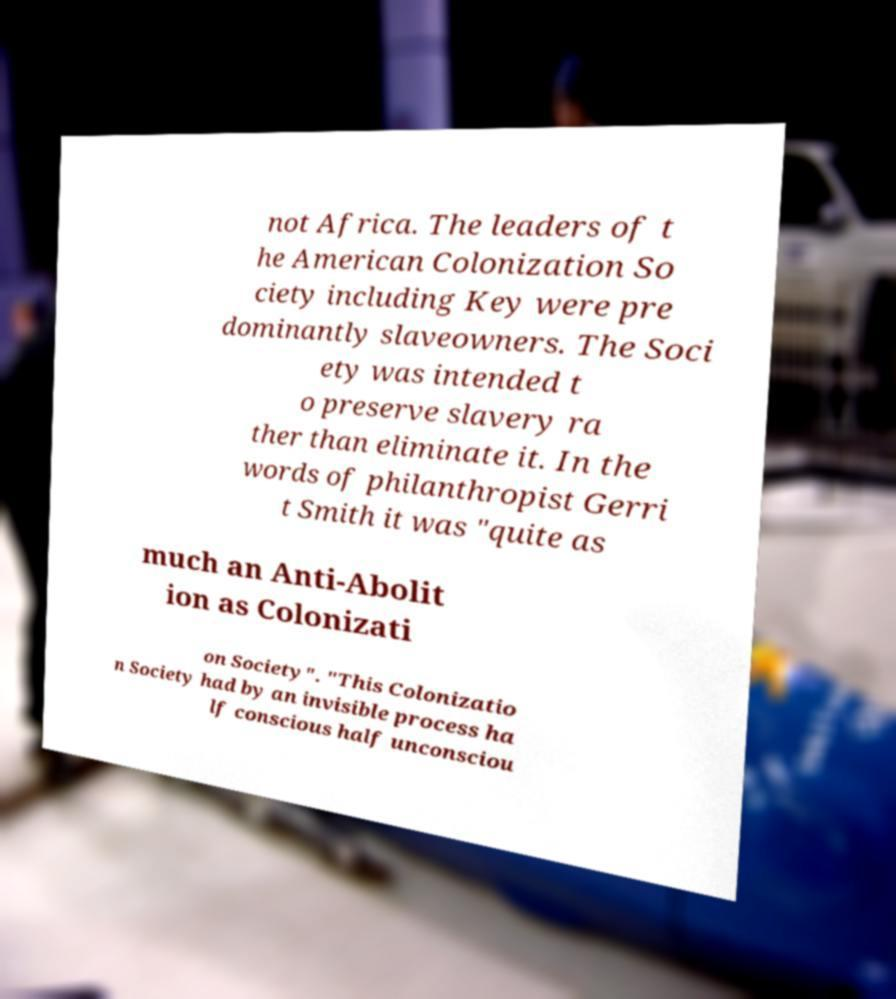What messages or text are displayed in this image? I need them in a readable, typed format. not Africa. The leaders of t he American Colonization So ciety including Key were pre dominantly slaveowners. The Soci ety was intended t o preserve slavery ra ther than eliminate it. In the words of philanthropist Gerri t Smith it was "quite as much an Anti-Abolit ion as Colonizati on Society". "This Colonizatio n Society had by an invisible process ha lf conscious half unconsciou 